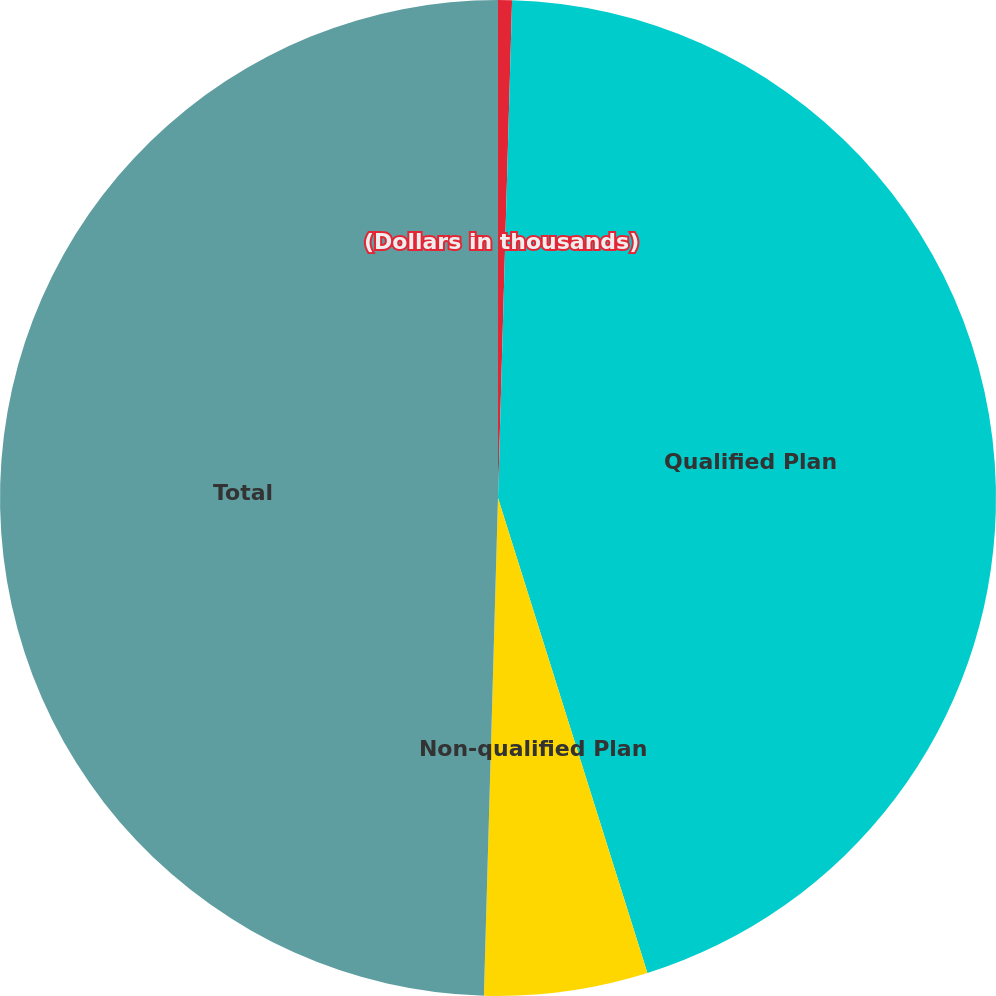<chart> <loc_0><loc_0><loc_500><loc_500><pie_chart><fcel>(Dollars in thousands)<fcel>Qualified Plan<fcel>Non-qualified Plan<fcel>Total<nl><fcel>0.45%<fcel>44.7%<fcel>5.3%<fcel>49.55%<nl></chart> 